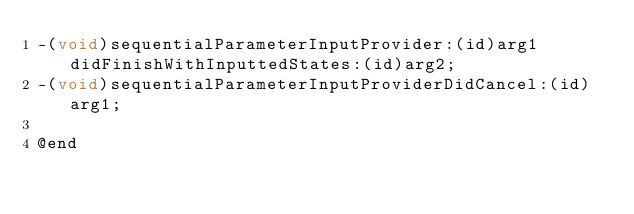Convert code to text. <code><loc_0><loc_0><loc_500><loc_500><_C_>-(void)sequentialParameterInputProvider:(id)arg1 didFinishWithInputtedStates:(id)arg2;
-(void)sequentialParameterInputProviderDidCancel:(id)arg1;

@end

</code> 